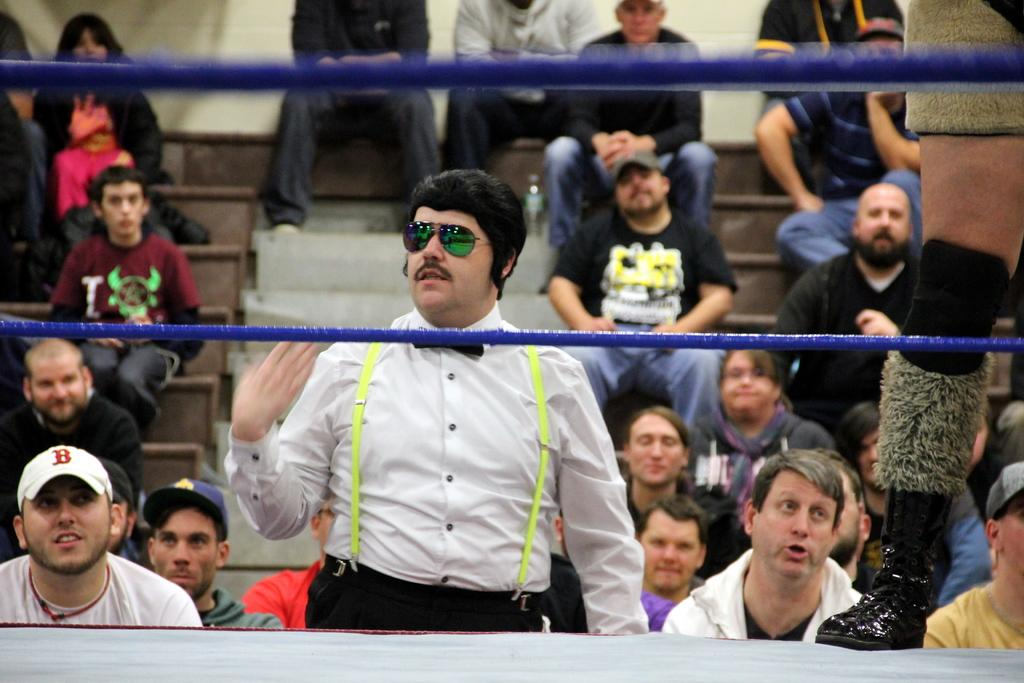What are the people in the image doing? The people in the image are sitting on stairs. Is there anyone standing in the image? Yes, there is a person standing in the image. What can be seen in front of the standing person? There is a blue color rope in front of the standing person. What type of bean is being used as a prop in the image? There is no bean present in the image. Can you hear the voice of the person standing in the image? The image is a still image, so we cannot hear any voices. 